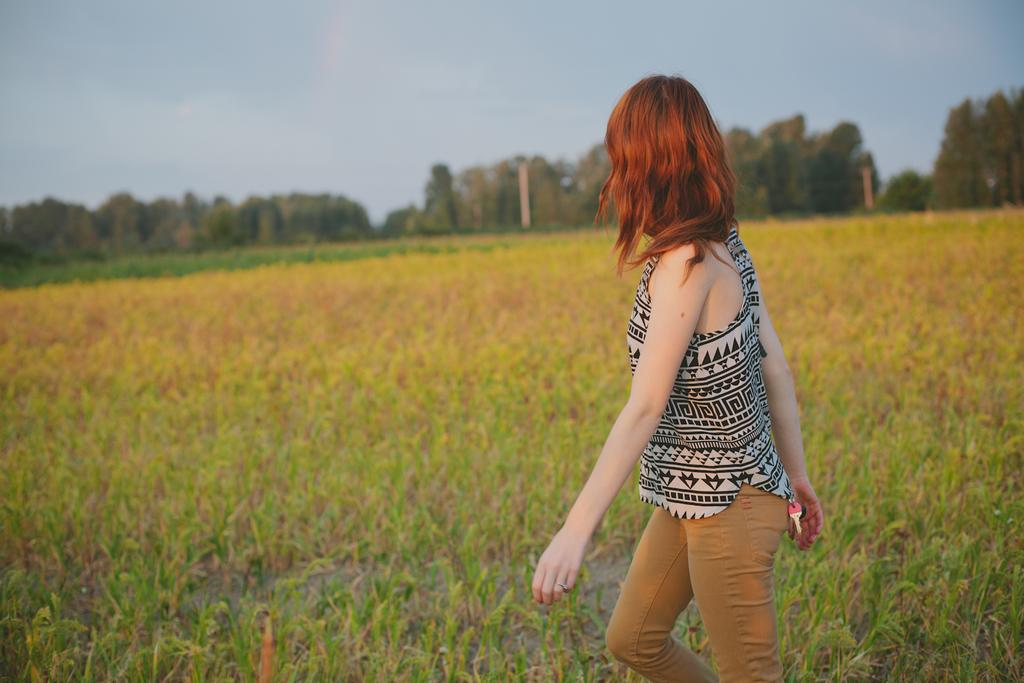Who is the main subject in the image? There is a girl in the image. What is the girl doing in the image? The girl is walking on the ground. What type of vegetation is present in the image? Grass is present in the image. What can be seen in the background of the image? There are trees and the sky visible in the background of the image. What type of glue is being used by the representative in the image? There is no representative or glue present in the image; it features a girl walking on the ground with grass, trees, and the sky in the background. 